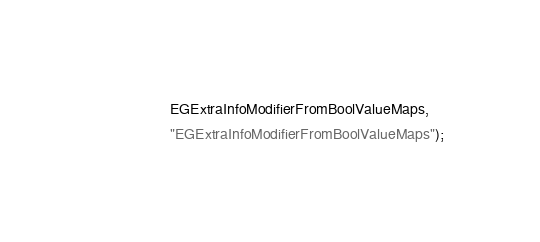Convert code to text. <code><loc_0><loc_0><loc_500><loc_500><_C++_>                  EGExtraInfoModifierFromBoolValueMaps,
                  "EGExtraInfoModifierFromBoolValueMaps");
</code> 